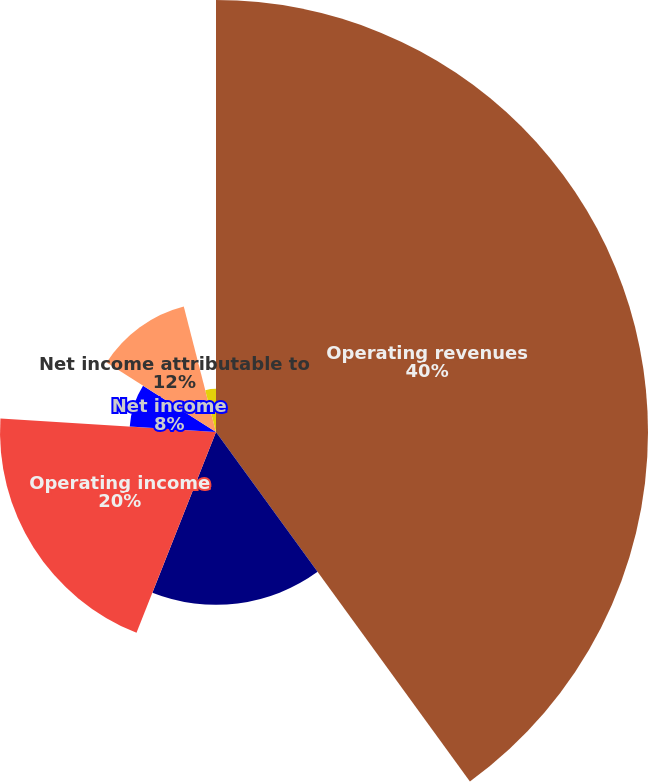Convert chart to OTSL. <chart><loc_0><loc_0><loc_500><loc_500><pie_chart><fcel>Operating revenues<fcel>Cost of operations (1)<fcel>Operating income<fcel>Net income<fcel>Net income attributable to<fcel>Basic net income per common<fcel>Diluted net income per common<nl><fcel>40.0%<fcel>16.0%<fcel>20.0%<fcel>8.0%<fcel>12.0%<fcel>0.0%<fcel>4.0%<nl></chart> 